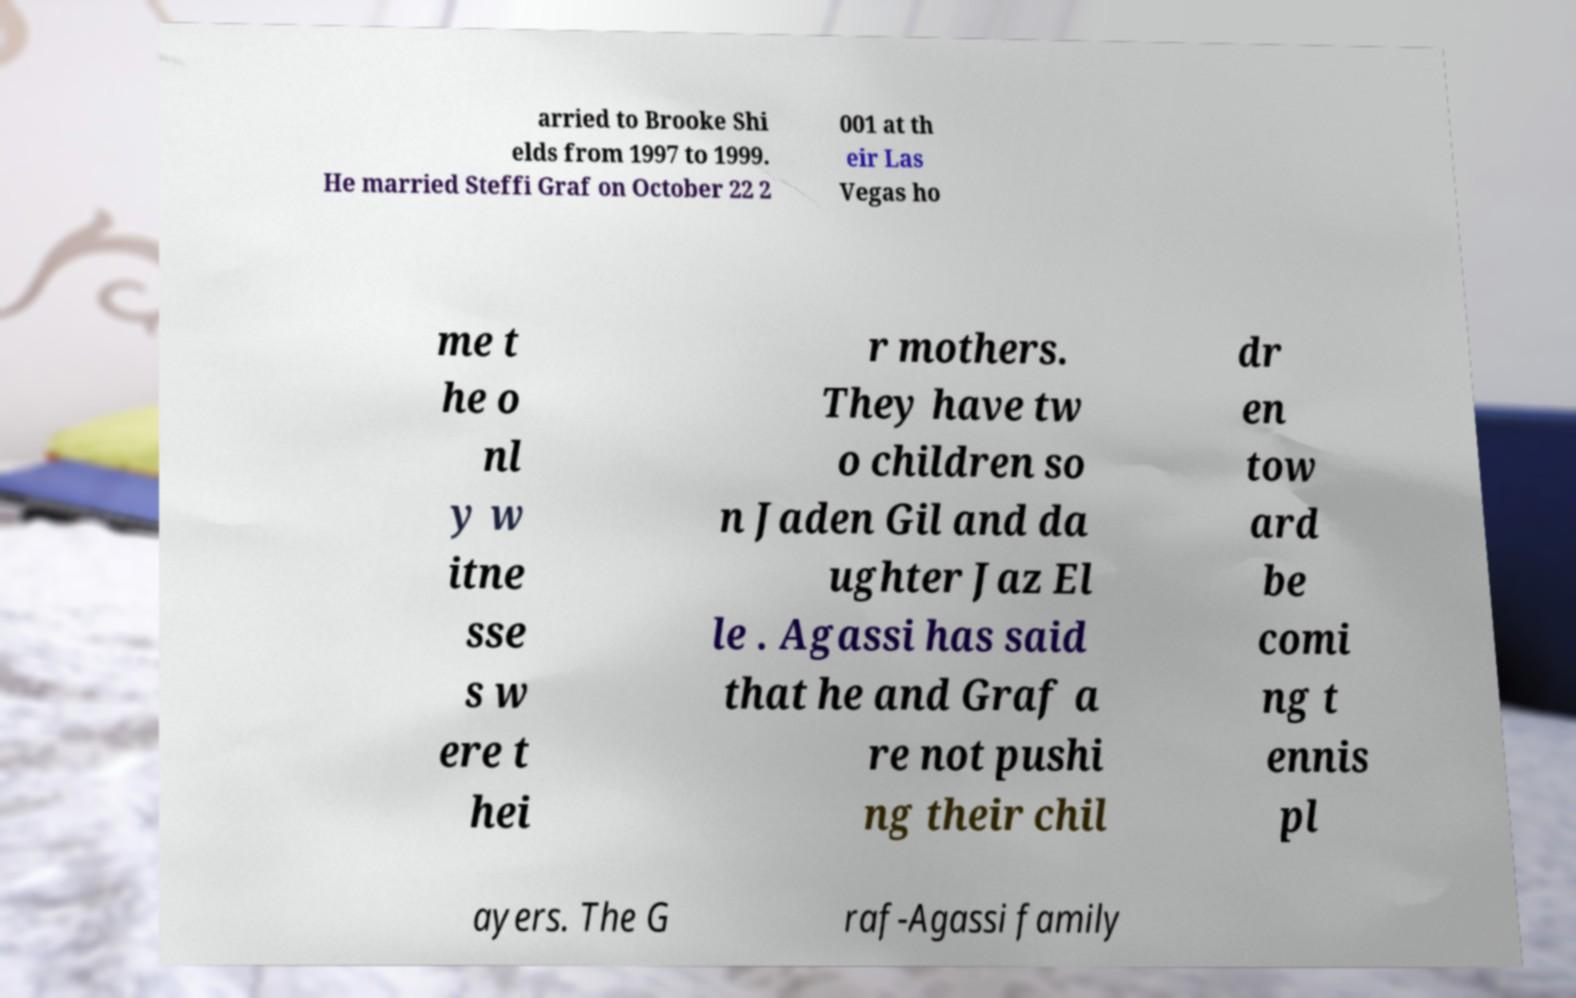For documentation purposes, I need the text within this image transcribed. Could you provide that? arried to Brooke Shi elds from 1997 to 1999. He married Steffi Graf on October 22 2 001 at th eir Las Vegas ho me t he o nl y w itne sse s w ere t hei r mothers. They have tw o children so n Jaden Gil and da ughter Jaz El le . Agassi has said that he and Graf a re not pushi ng their chil dr en tow ard be comi ng t ennis pl ayers. The G raf-Agassi family 